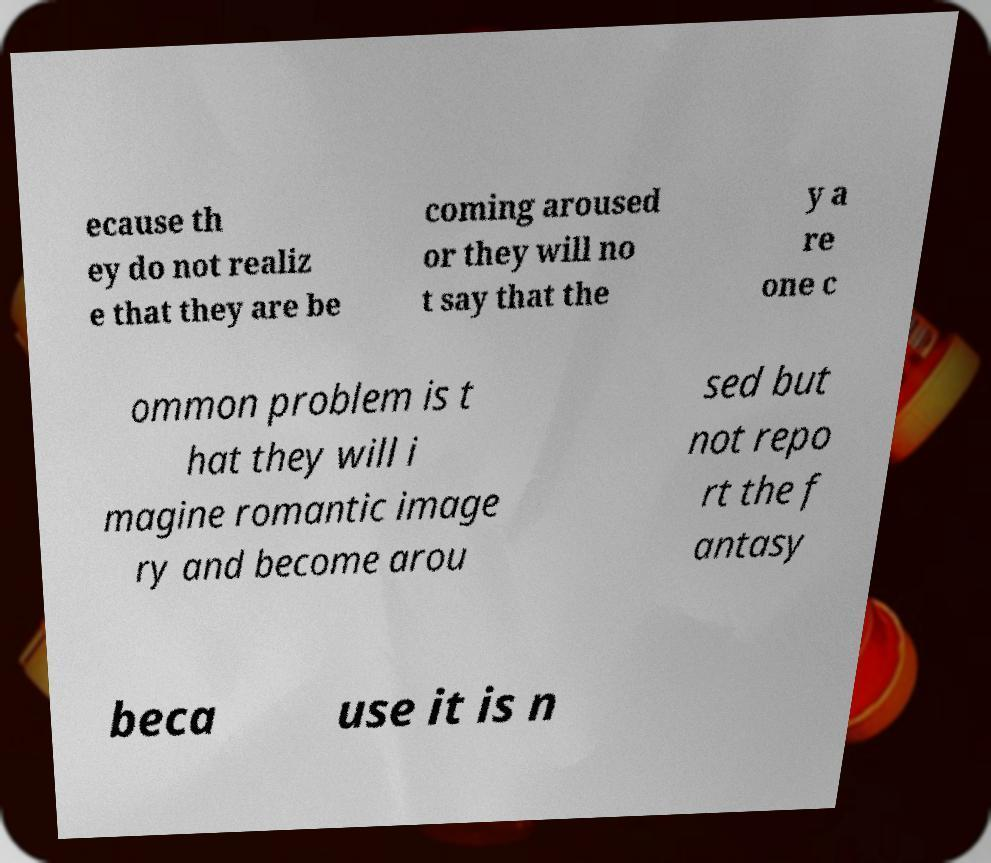For documentation purposes, I need the text within this image transcribed. Could you provide that? ecause th ey do not realiz e that they are be coming aroused or they will no t say that the y a re one c ommon problem is t hat they will i magine romantic image ry and become arou sed but not repo rt the f antasy beca use it is n 